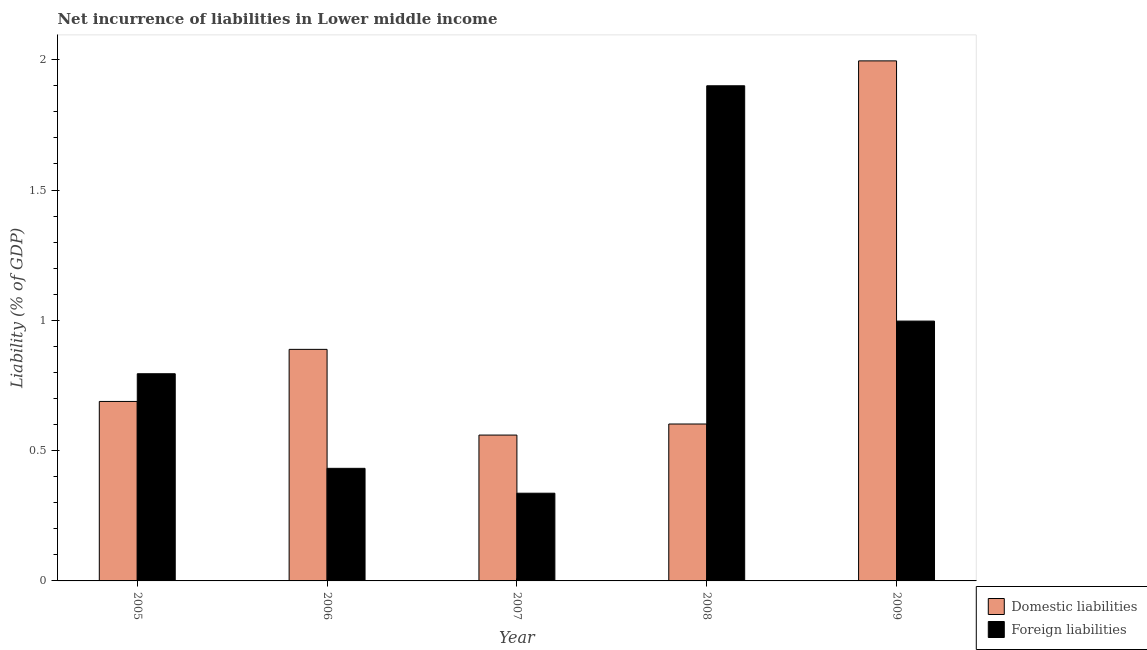How many different coloured bars are there?
Your response must be concise. 2. What is the label of the 1st group of bars from the left?
Your response must be concise. 2005. In how many cases, is the number of bars for a given year not equal to the number of legend labels?
Your answer should be very brief. 0. What is the incurrence of foreign liabilities in 2006?
Offer a terse response. 0.43. Across all years, what is the maximum incurrence of domestic liabilities?
Keep it short and to the point. 2. Across all years, what is the minimum incurrence of domestic liabilities?
Offer a terse response. 0.56. In which year was the incurrence of foreign liabilities maximum?
Make the answer very short. 2008. In which year was the incurrence of foreign liabilities minimum?
Your answer should be compact. 2007. What is the total incurrence of domestic liabilities in the graph?
Your response must be concise. 4.73. What is the difference between the incurrence of domestic liabilities in 2006 and that in 2009?
Make the answer very short. -1.11. What is the difference between the incurrence of foreign liabilities in 2008 and the incurrence of domestic liabilities in 2006?
Provide a short and direct response. 1.47. What is the average incurrence of foreign liabilities per year?
Keep it short and to the point. 0.89. In the year 2007, what is the difference between the incurrence of domestic liabilities and incurrence of foreign liabilities?
Provide a short and direct response. 0. In how many years, is the incurrence of foreign liabilities greater than 1.2 %?
Provide a short and direct response. 1. What is the ratio of the incurrence of foreign liabilities in 2006 to that in 2009?
Give a very brief answer. 0.43. Is the difference between the incurrence of domestic liabilities in 2005 and 2009 greater than the difference between the incurrence of foreign liabilities in 2005 and 2009?
Make the answer very short. No. What is the difference between the highest and the second highest incurrence of foreign liabilities?
Keep it short and to the point. 0.9. What is the difference between the highest and the lowest incurrence of domestic liabilities?
Keep it short and to the point. 1.44. What does the 2nd bar from the left in 2006 represents?
Provide a succinct answer. Foreign liabilities. What does the 2nd bar from the right in 2006 represents?
Your response must be concise. Domestic liabilities. Are the values on the major ticks of Y-axis written in scientific E-notation?
Provide a short and direct response. No. How many legend labels are there?
Your response must be concise. 2. What is the title of the graph?
Your response must be concise. Net incurrence of liabilities in Lower middle income. What is the label or title of the Y-axis?
Your response must be concise. Liability (% of GDP). What is the Liability (% of GDP) of Domestic liabilities in 2005?
Provide a succinct answer. 0.69. What is the Liability (% of GDP) in Foreign liabilities in 2005?
Offer a terse response. 0.8. What is the Liability (% of GDP) in Domestic liabilities in 2006?
Your response must be concise. 0.89. What is the Liability (% of GDP) of Foreign liabilities in 2006?
Provide a short and direct response. 0.43. What is the Liability (% of GDP) in Domestic liabilities in 2007?
Your response must be concise. 0.56. What is the Liability (% of GDP) in Foreign liabilities in 2007?
Provide a short and direct response. 0.34. What is the Liability (% of GDP) in Domestic liabilities in 2008?
Ensure brevity in your answer.  0.6. What is the Liability (% of GDP) in Foreign liabilities in 2008?
Your answer should be very brief. 1.9. What is the Liability (% of GDP) of Domestic liabilities in 2009?
Make the answer very short. 2. What is the Liability (% of GDP) in Foreign liabilities in 2009?
Keep it short and to the point. 1. Across all years, what is the maximum Liability (% of GDP) of Domestic liabilities?
Offer a terse response. 2. Across all years, what is the maximum Liability (% of GDP) in Foreign liabilities?
Keep it short and to the point. 1.9. Across all years, what is the minimum Liability (% of GDP) in Domestic liabilities?
Your response must be concise. 0.56. Across all years, what is the minimum Liability (% of GDP) of Foreign liabilities?
Make the answer very short. 0.34. What is the total Liability (% of GDP) of Domestic liabilities in the graph?
Make the answer very short. 4.73. What is the total Liability (% of GDP) of Foreign liabilities in the graph?
Your answer should be very brief. 4.46. What is the difference between the Liability (% of GDP) in Domestic liabilities in 2005 and that in 2006?
Your response must be concise. -0.2. What is the difference between the Liability (% of GDP) of Foreign liabilities in 2005 and that in 2006?
Ensure brevity in your answer.  0.36. What is the difference between the Liability (% of GDP) in Domestic liabilities in 2005 and that in 2007?
Provide a short and direct response. 0.13. What is the difference between the Liability (% of GDP) in Foreign liabilities in 2005 and that in 2007?
Your answer should be very brief. 0.46. What is the difference between the Liability (% of GDP) of Domestic liabilities in 2005 and that in 2008?
Give a very brief answer. 0.09. What is the difference between the Liability (% of GDP) in Foreign liabilities in 2005 and that in 2008?
Keep it short and to the point. -1.1. What is the difference between the Liability (% of GDP) in Domestic liabilities in 2005 and that in 2009?
Provide a succinct answer. -1.31. What is the difference between the Liability (% of GDP) of Foreign liabilities in 2005 and that in 2009?
Keep it short and to the point. -0.2. What is the difference between the Liability (% of GDP) in Domestic liabilities in 2006 and that in 2007?
Offer a very short reply. 0.33. What is the difference between the Liability (% of GDP) in Foreign liabilities in 2006 and that in 2007?
Your answer should be compact. 0.1. What is the difference between the Liability (% of GDP) in Domestic liabilities in 2006 and that in 2008?
Provide a short and direct response. 0.29. What is the difference between the Liability (% of GDP) of Foreign liabilities in 2006 and that in 2008?
Offer a very short reply. -1.47. What is the difference between the Liability (% of GDP) of Domestic liabilities in 2006 and that in 2009?
Provide a succinct answer. -1.11. What is the difference between the Liability (% of GDP) of Foreign liabilities in 2006 and that in 2009?
Offer a very short reply. -0.56. What is the difference between the Liability (% of GDP) of Domestic liabilities in 2007 and that in 2008?
Your answer should be very brief. -0.04. What is the difference between the Liability (% of GDP) of Foreign liabilities in 2007 and that in 2008?
Your answer should be very brief. -1.56. What is the difference between the Liability (% of GDP) in Domestic liabilities in 2007 and that in 2009?
Provide a succinct answer. -1.44. What is the difference between the Liability (% of GDP) of Foreign liabilities in 2007 and that in 2009?
Provide a short and direct response. -0.66. What is the difference between the Liability (% of GDP) in Domestic liabilities in 2008 and that in 2009?
Your answer should be very brief. -1.39. What is the difference between the Liability (% of GDP) in Foreign liabilities in 2008 and that in 2009?
Provide a short and direct response. 0.9. What is the difference between the Liability (% of GDP) of Domestic liabilities in 2005 and the Liability (% of GDP) of Foreign liabilities in 2006?
Offer a terse response. 0.26. What is the difference between the Liability (% of GDP) in Domestic liabilities in 2005 and the Liability (% of GDP) in Foreign liabilities in 2007?
Ensure brevity in your answer.  0.35. What is the difference between the Liability (% of GDP) in Domestic liabilities in 2005 and the Liability (% of GDP) in Foreign liabilities in 2008?
Make the answer very short. -1.21. What is the difference between the Liability (% of GDP) of Domestic liabilities in 2005 and the Liability (% of GDP) of Foreign liabilities in 2009?
Give a very brief answer. -0.31. What is the difference between the Liability (% of GDP) in Domestic liabilities in 2006 and the Liability (% of GDP) in Foreign liabilities in 2007?
Make the answer very short. 0.55. What is the difference between the Liability (% of GDP) in Domestic liabilities in 2006 and the Liability (% of GDP) in Foreign liabilities in 2008?
Keep it short and to the point. -1.01. What is the difference between the Liability (% of GDP) of Domestic liabilities in 2006 and the Liability (% of GDP) of Foreign liabilities in 2009?
Offer a terse response. -0.11. What is the difference between the Liability (% of GDP) of Domestic liabilities in 2007 and the Liability (% of GDP) of Foreign liabilities in 2008?
Provide a short and direct response. -1.34. What is the difference between the Liability (% of GDP) in Domestic liabilities in 2007 and the Liability (% of GDP) in Foreign liabilities in 2009?
Your answer should be compact. -0.44. What is the difference between the Liability (% of GDP) of Domestic liabilities in 2008 and the Liability (% of GDP) of Foreign liabilities in 2009?
Your response must be concise. -0.39. What is the average Liability (% of GDP) of Domestic liabilities per year?
Ensure brevity in your answer.  0.95. What is the average Liability (% of GDP) of Foreign liabilities per year?
Give a very brief answer. 0.89. In the year 2005, what is the difference between the Liability (% of GDP) of Domestic liabilities and Liability (% of GDP) of Foreign liabilities?
Keep it short and to the point. -0.11. In the year 2006, what is the difference between the Liability (% of GDP) in Domestic liabilities and Liability (% of GDP) in Foreign liabilities?
Make the answer very short. 0.46. In the year 2007, what is the difference between the Liability (% of GDP) of Domestic liabilities and Liability (% of GDP) of Foreign liabilities?
Your answer should be very brief. 0.22. In the year 2008, what is the difference between the Liability (% of GDP) in Domestic liabilities and Liability (% of GDP) in Foreign liabilities?
Make the answer very short. -1.3. What is the ratio of the Liability (% of GDP) of Domestic liabilities in 2005 to that in 2006?
Offer a very short reply. 0.78. What is the ratio of the Liability (% of GDP) in Foreign liabilities in 2005 to that in 2006?
Provide a succinct answer. 1.84. What is the ratio of the Liability (% of GDP) of Domestic liabilities in 2005 to that in 2007?
Provide a succinct answer. 1.23. What is the ratio of the Liability (% of GDP) in Foreign liabilities in 2005 to that in 2007?
Provide a succinct answer. 2.36. What is the ratio of the Liability (% of GDP) in Domestic liabilities in 2005 to that in 2008?
Keep it short and to the point. 1.14. What is the ratio of the Liability (% of GDP) of Foreign liabilities in 2005 to that in 2008?
Your answer should be very brief. 0.42. What is the ratio of the Liability (% of GDP) of Domestic liabilities in 2005 to that in 2009?
Your answer should be compact. 0.35. What is the ratio of the Liability (% of GDP) in Foreign liabilities in 2005 to that in 2009?
Provide a succinct answer. 0.8. What is the ratio of the Liability (% of GDP) in Domestic liabilities in 2006 to that in 2007?
Your response must be concise. 1.59. What is the ratio of the Liability (% of GDP) in Foreign liabilities in 2006 to that in 2007?
Provide a succinct answer. 1.28. What is the ratio of the Liability (% of GDP) of Domestic liabilities in 2006 to that in 2008?
Give a very brief answer. 1.48. What is the ratio of the Liability (% of GDP) in Foreign liabilities in 2006 to that in 2008?
Make the answer very short. 0.23. What is the ratio of the Liability (% of GDP) in Domestic liabilities in 2006 to that in 2009?
Provide a succinct answer. 0.45. What is the ratio of the Liability (% of GDP) in Foreign liabilities in 2006 to that in 2009?
Your answer should be compact. 0.43. What is the ratio of the Liability (% of GDP) in Domestic liabilities in 2007 to that in 2008?
Provide a succinct answer. 0.93. What is the ratio of the Liability (% of GDP) of Foreign liabilities in 2007 to that in 2008?
Offer a very short reply. 0.18. What is the ratio of the Liability (% of GDP) of Domestic liabilities in 2007 to that in 2009?
Make the answer very short. 0.28. What is the ratio of the Liability (% of GDP) in Foreign liabilities in 2007 to that in 2009?
Your answer should be compact. 0.34. What is the ratio of the Liability (% of GDP) in Domestic liabilities in 2008 to that in 2009?
Offer a very short reply. 0.3. What is the ratio of the Liability (% of GDP) in Foreign liabilities in 2008 to that in 2009?
Provide a short and direct response. 1.91. What is the difference between the highest and the second highest Liability (% of GDP) of Domestic liabilities?
Offer a terse response. 1.11. What is the difference between the highest and the second highest Liability (% of GDP) of Foreign liabilities?
Offer a very short reply. 0.9. What is the difference between the highest and the lowest Liability (% of GDP) in Domestic liabilities?
Your answer should be compact. 1.44. What is the difference between the highest and the lowest Liability (% of GDP) in Foreign liabilities?
Provide a succinct answer. 1.56. 